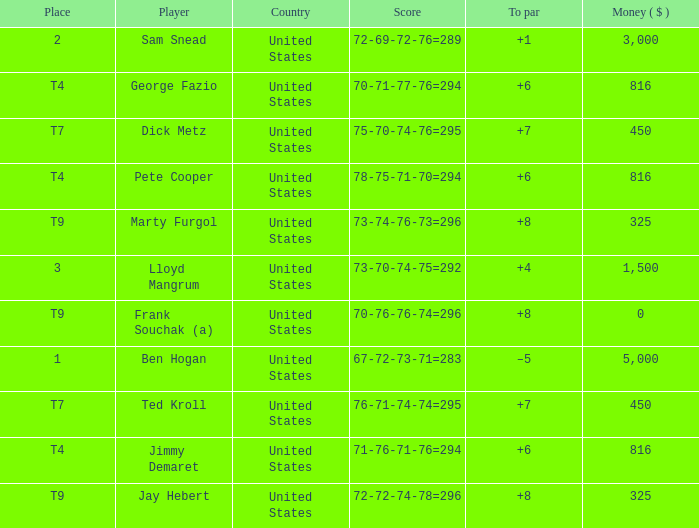What was Marty Furgol's place when he was paid less than $3,000? T9. 